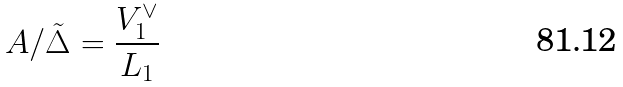<formula> <loc_0><loc_0><loc_500><loc_500>A / \tilde { \Delta } = \frac { V _ { 1 } ^ { \vee } } { L _ { 1 } }</formula> 